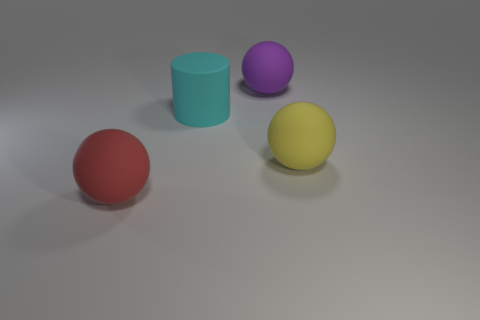Add 1 big purple things. How many objects exist? 5 Subtract all balls. How many objects are left? 1 Add 2 large brown shiny blocks. How many large brown shiny blocks exist? 2 Subtract 0 brown balls. How many objects are left? 4 Subtract all purple balls. Subtract all matte cylinders. How many objects are left? 2 Add 3 red matte things. How many red matte things are left? 4 